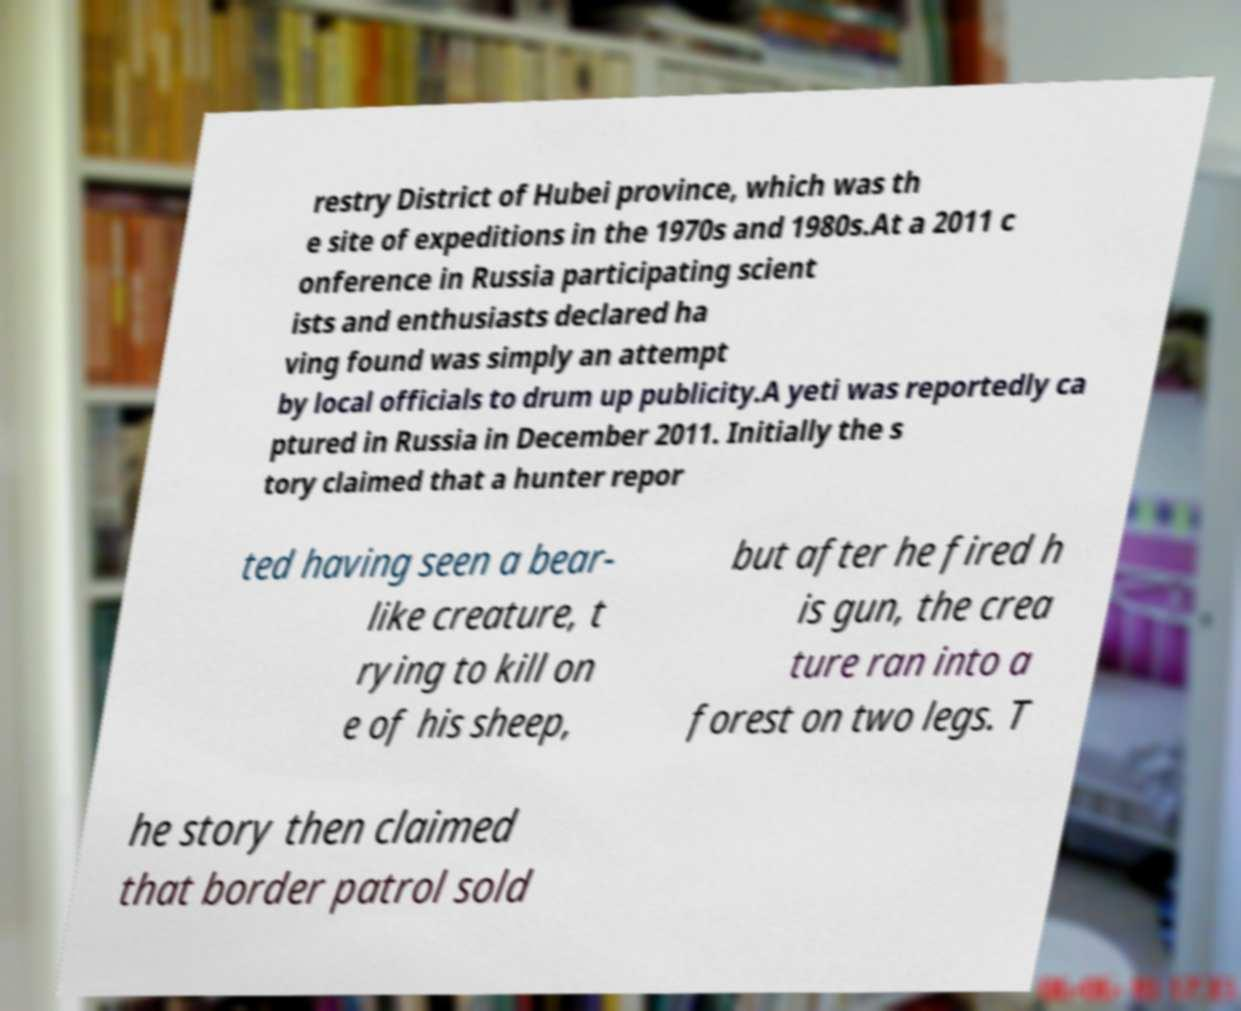I need the written content from this picture converted into text. Can you do that? restry District of Hubei province, which was th e site of expeditions in the 1970s and 1980s.At a 2011 c onference in Russia participating scient ists and enthusiasts declared ha ving found was simply an attempt by local officials to drum up publicity.A yeti was reportedly ca ptured in Russia in December 2011. Initially the s tory claimed that a hunter repor ted having seen a bear- like creature, t rying to kill on e of his sheep, but after he fired h is gun, the crea ture ran into a forest on two legs. T he story then claimed that border patrol sold 